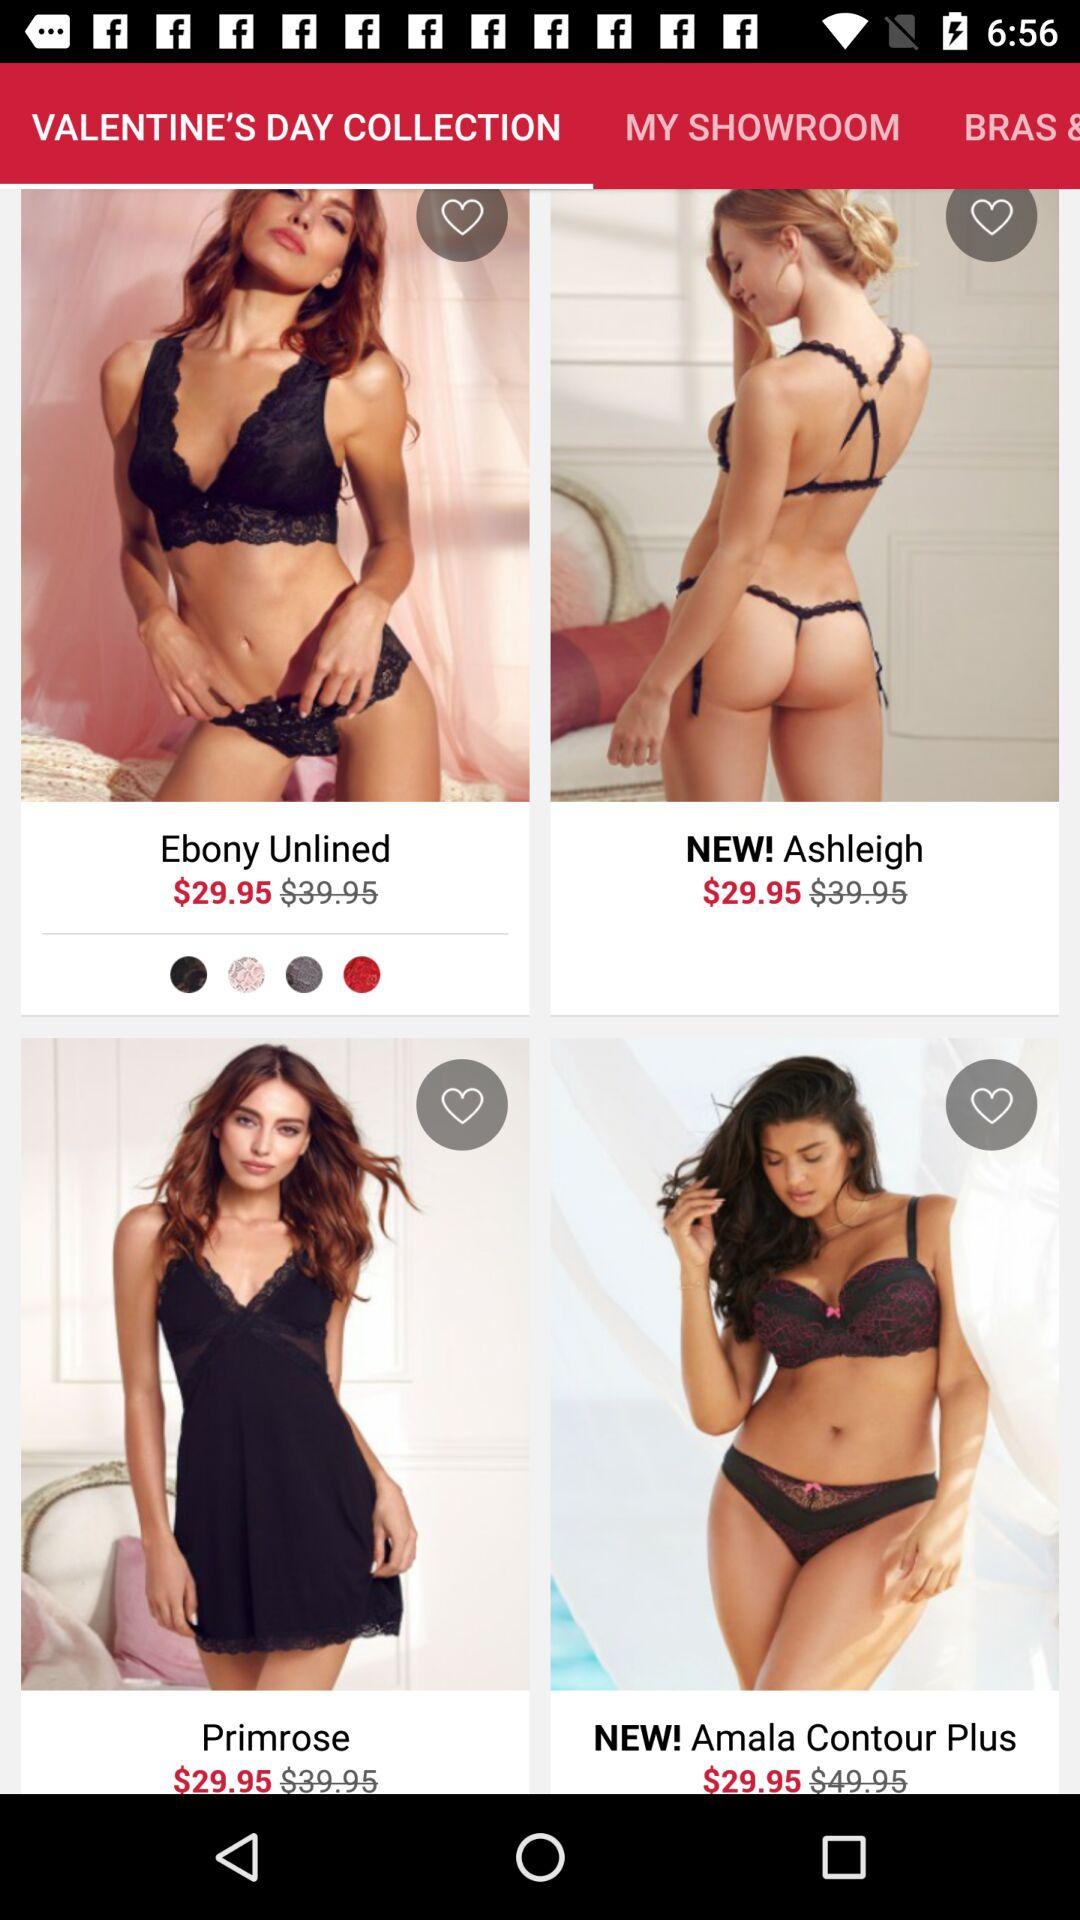What is the currency for the price of "Ebony Unlined"? The currency is "Dollar". 